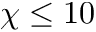<formula> <loc_0><loc_0><loc_500><loc_500>\chi \leq 1 0</formula> 